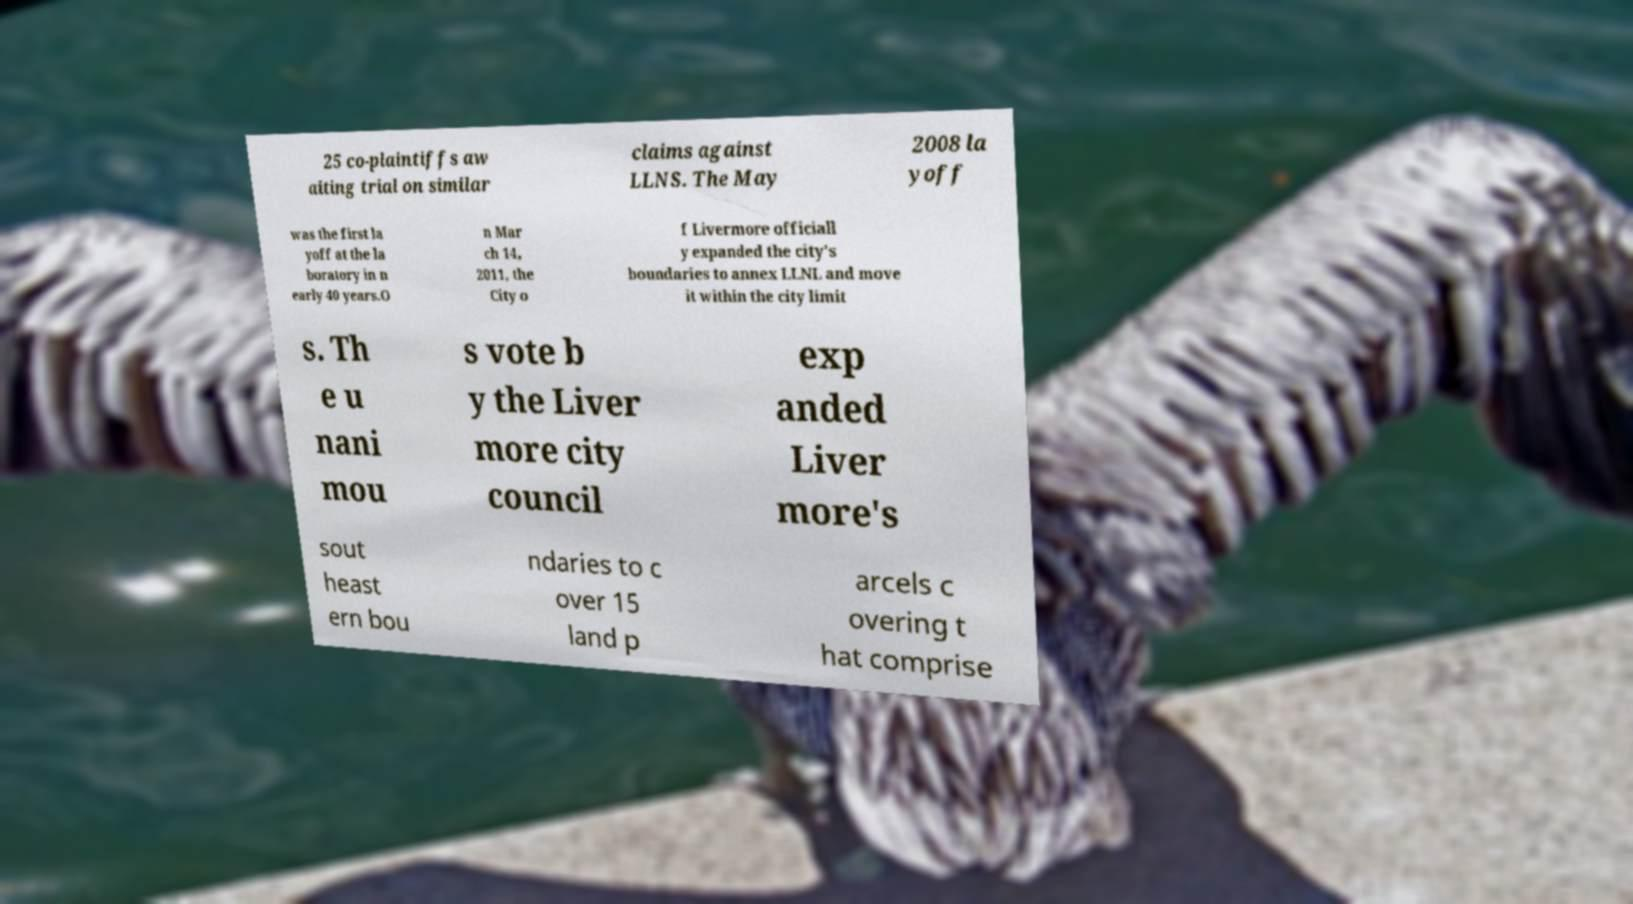Please identify and transcribe the text found in this image. 25 co-plaintiffs aw aiting trial on similar claims against LLNS. The May 2008 la yoff was the first la yoff at the la boratory in n early 40 years.O n Mar ch 14, 2011, the City o f Livermore officiall y expanded the city's boundaries to annex LLNL and move it within the city limit s. Th e u nani mou s vote b y the Liver more city council exp anded Liver more's sout heast ern bou ndaries to c over 15 land p arcels c overing t hat comprise 